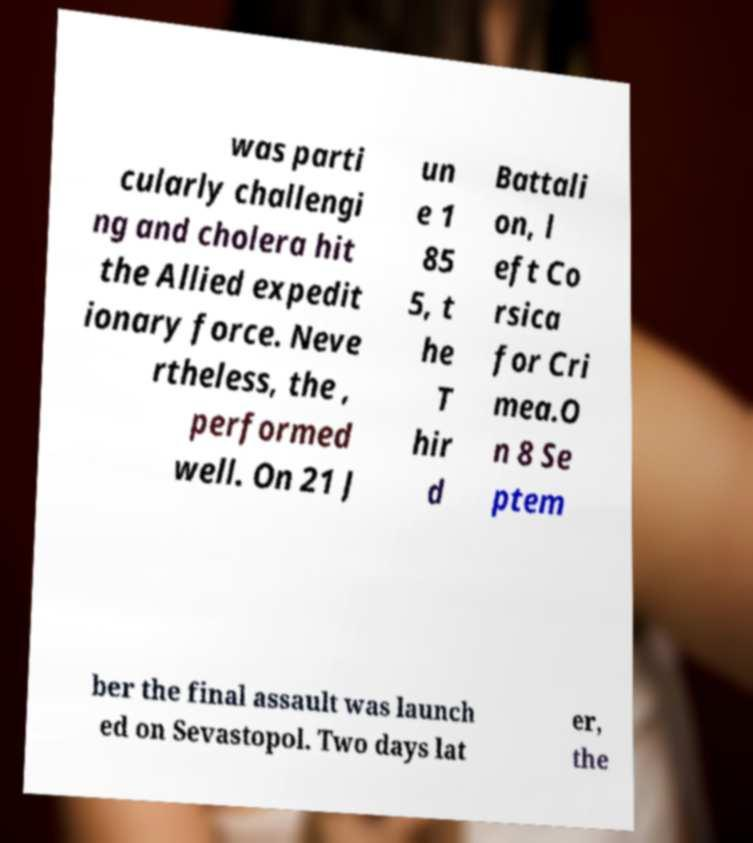For documentation purposes, I need the text within this image transcribed. Could you provide that? was parti cularly challengi ng and cholera hit the Allied expedit ionary force. Neve rtheless, the , performed well. On 21 J un e 1 85 5, t he T hir d Battali on, l eft Co rsica for Cri mea.O n 8 Se ptem ber the final assault was launch ed on Sevastopol. Two days lat er, the 